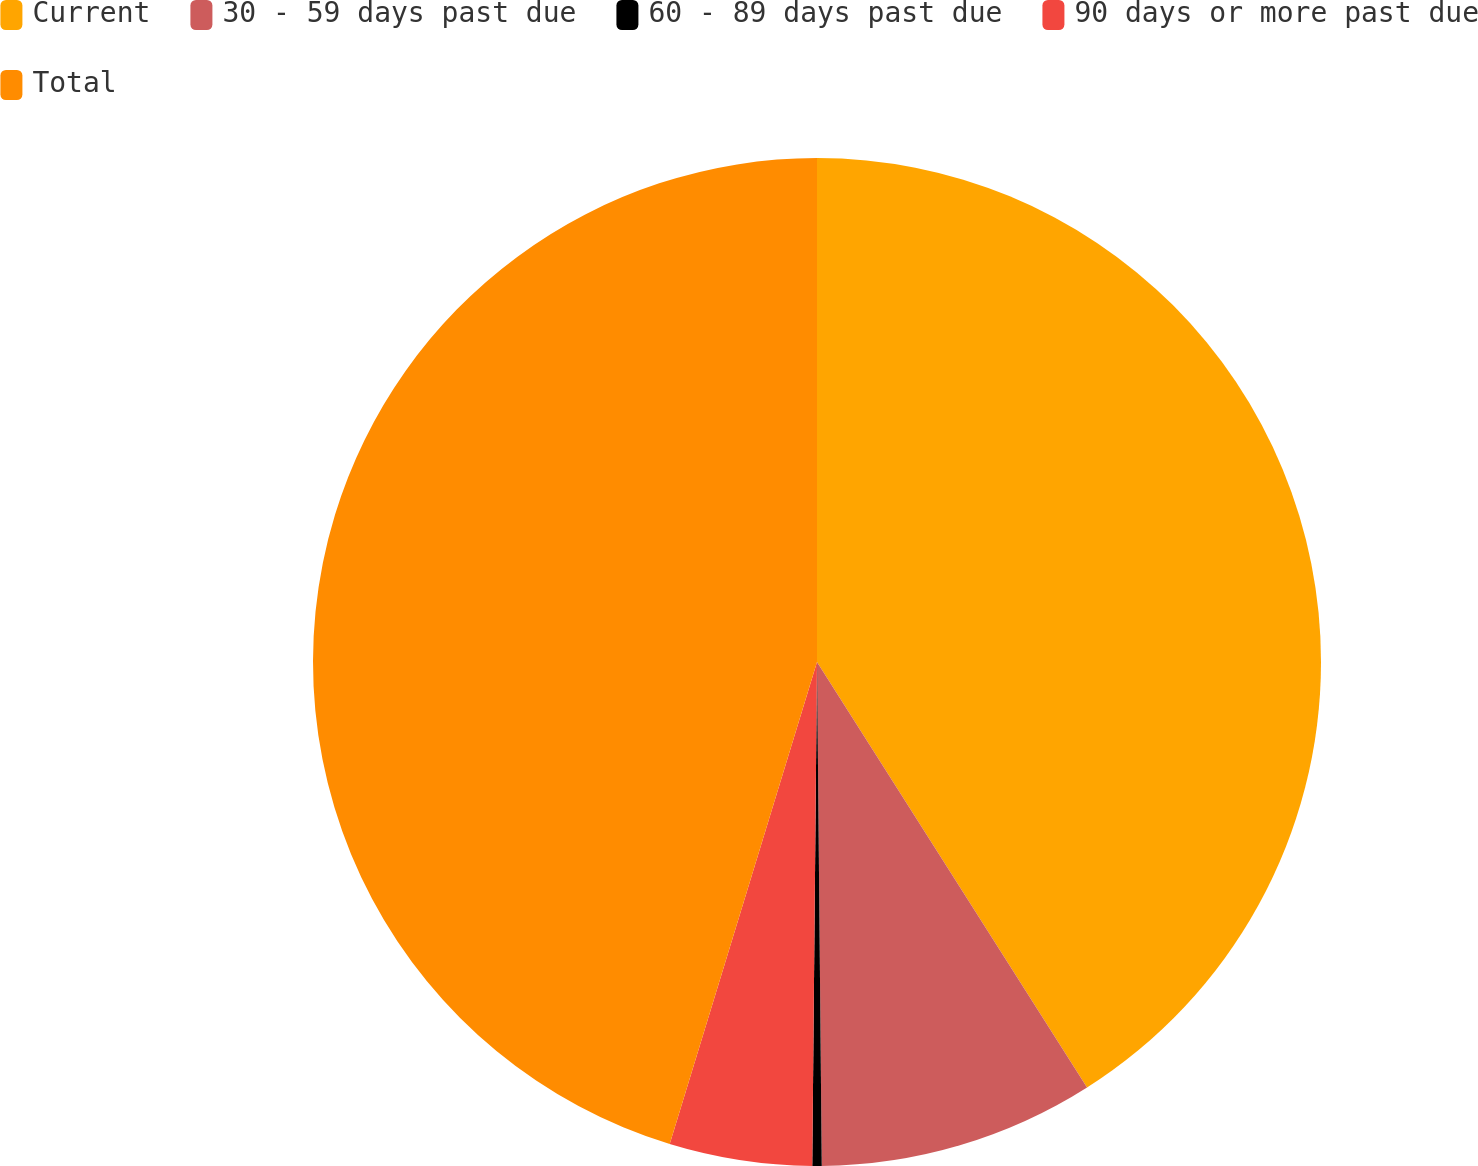<chart> <loc_0><loc_0><loc_500><loc_500><pie_chart><fcel>Current<fcel>30 - 59 days past due<fcel>60 - 89 days past due<fcel>90 days or more past due<fcel>Total<nl><fcel>41.0%<fcel>8.85%<fcel>0.3%<fcel>4.57%<fcel>45.28%<nl></chart> 